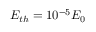<formula> <loc_0><loc_0><loc_500><loc_500>E _ { t h } = 1 0 ^ { - 5 } E _ { 0 }</formula> 